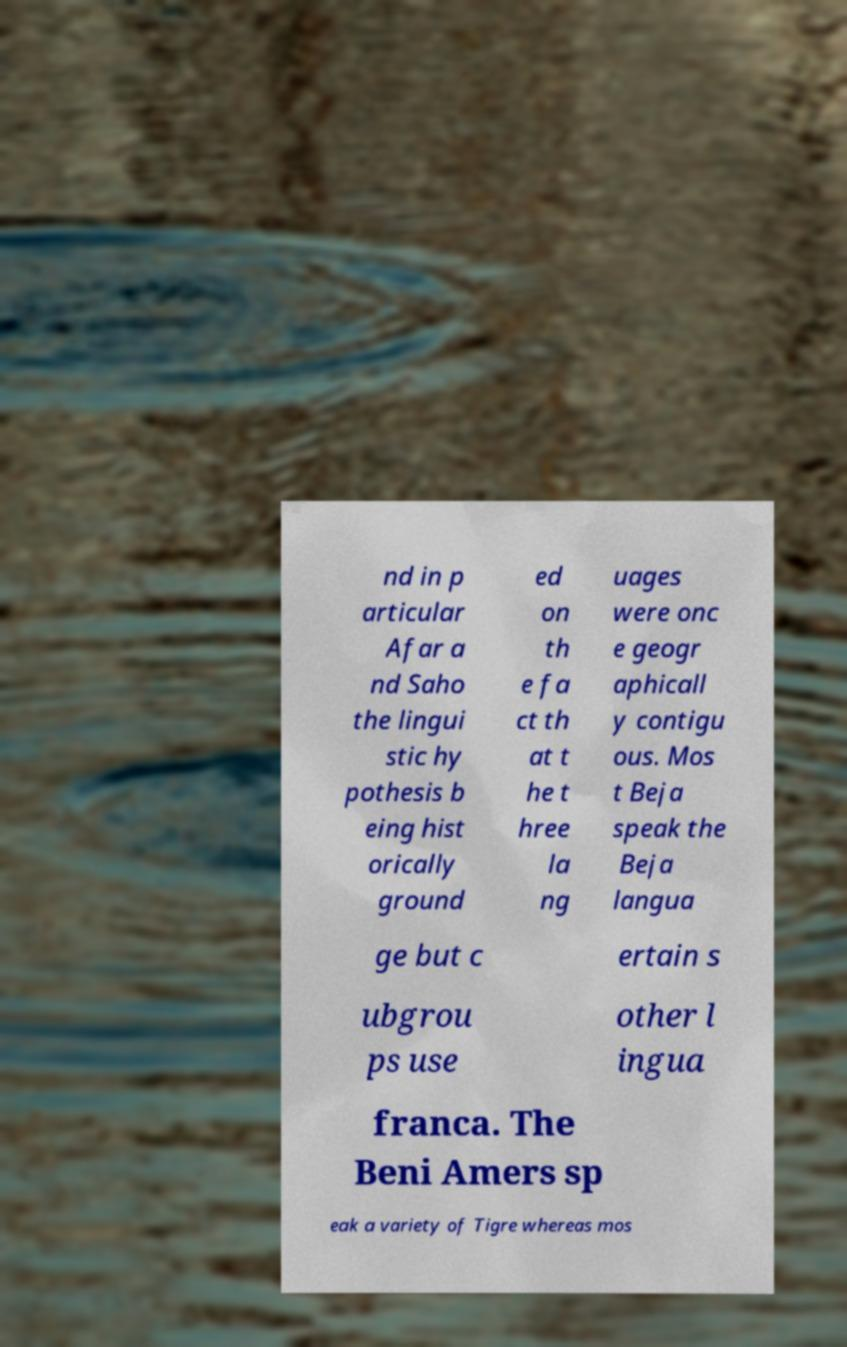Please read and relay the text visible in this image. What does it say? nd in p articular Afar a nd Saho the lingui stic hy pothesis b eing hist orically ground ed on th e fa ct th at t he t hree la ng uages were onc e geogr aphicall y contigu ous. Mos t Beja speak the Beja langua ge but c ertain s ubgrou ps use other l ingua franca. The Beni Amers sp eak a variety of Tigre whereas mos 